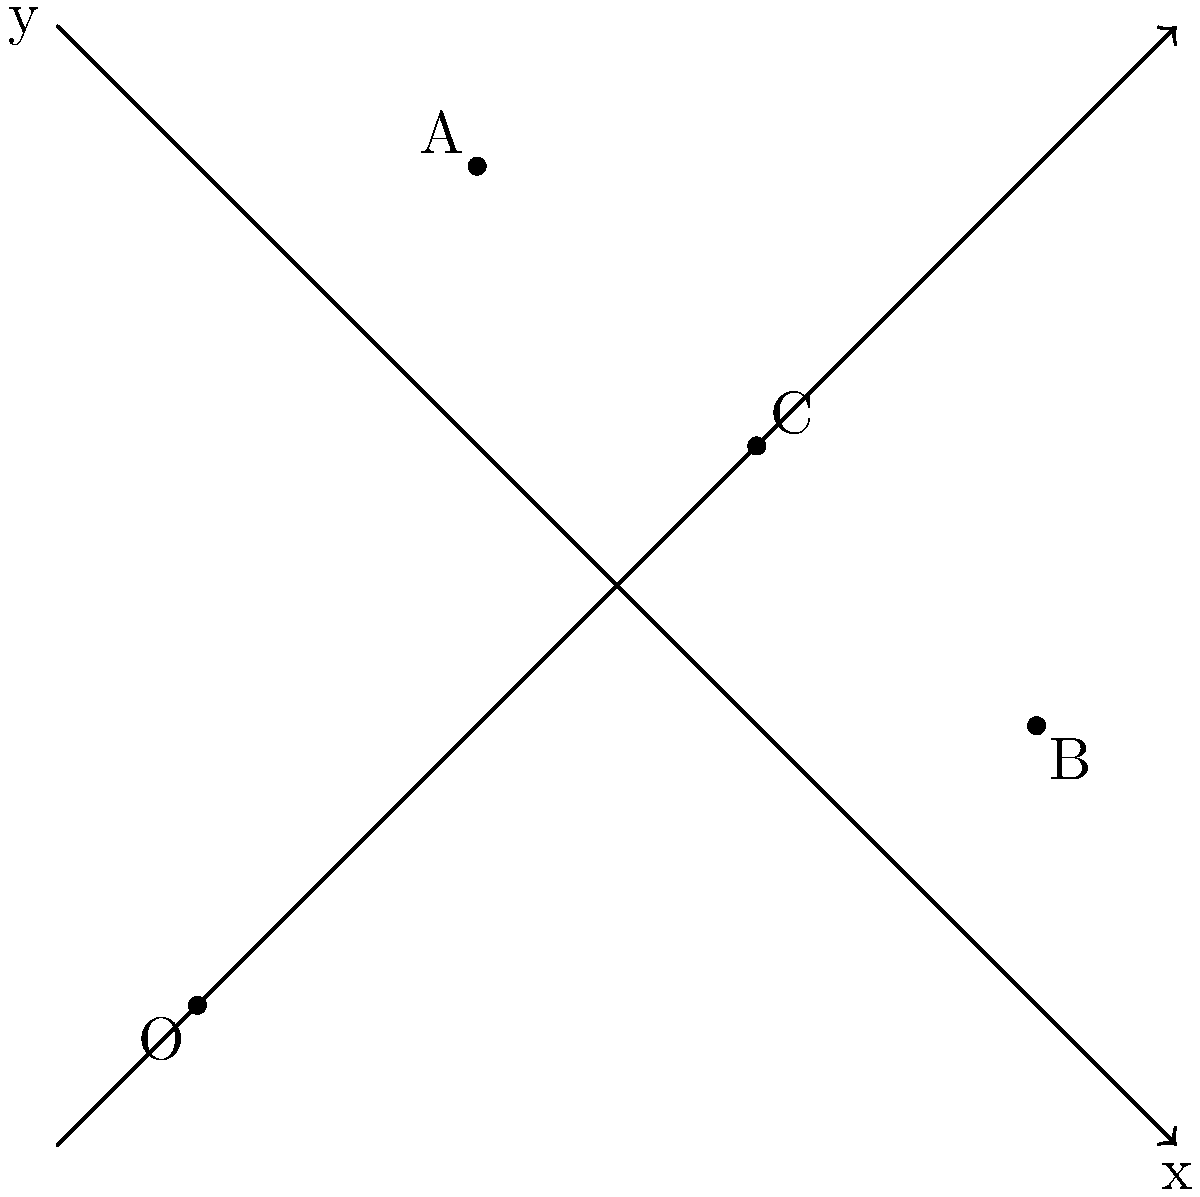In a military operation, two fighter jets are following different flight paths. Jet Alpha's path is represented by the equation $y = -x + 8$, while Jet Bravo's path is given by $y = x$. Using the coordinate system shown, determine the coordinates of the point where the two flight paths intersect. How would this information be crucial in coordinating the mission? To find the point of intersection, we need to solve the system of equations:

1) Jet Alpha's path: $y = -x + 8$
2) Jet Bravo's path: $y = x$

At the point of intersection, the $y$ values will be equal. So we can set the right sides of the equations equal to each other:

$-x + 8 = x$

Now, let's solve for $x$:

$-x + 8 = x$
$8 = 2x$
$x = 4$

To find $y$, we can substitute $x = 4$ into either equation. Let's use Jet Bravo's equation:

$y = x = 4$

Therefore, the point of intersection is $(4, 4)$.

This information is crucial for mission coordination as it represents a potential collision point. Knowing this allows for:
1) Adjusting flight paths to avoid collision
2) Coordinating a precise rendezvous point if needed
3) Calculating timing for synchronized maneuvers
4) Establishing a reference point for communication and navigation
Answer: $(4, 4)$ 